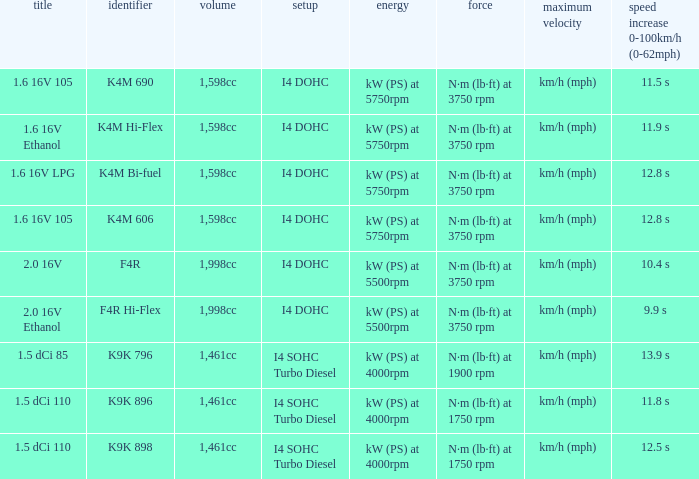What is the code of 1.5 dci 110, which has a capacity of 1,461cc? K9K 896, K9K 898. 